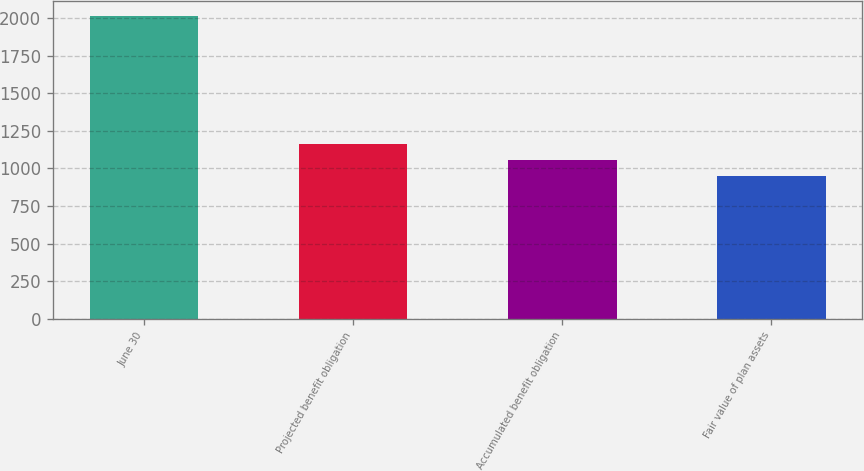Convert chart. <chart><loc_0><loc_0><loc_500><loc_500><bar_chart><fcel>June 30<fcel>Projected benefit obligation<fcel>Accumulated benefit obligation<fcel>Fair value of plan assets<nl><fcel>2010<fcel>1162.8<fcel>1056.9<fcel>951<nl></chart> 